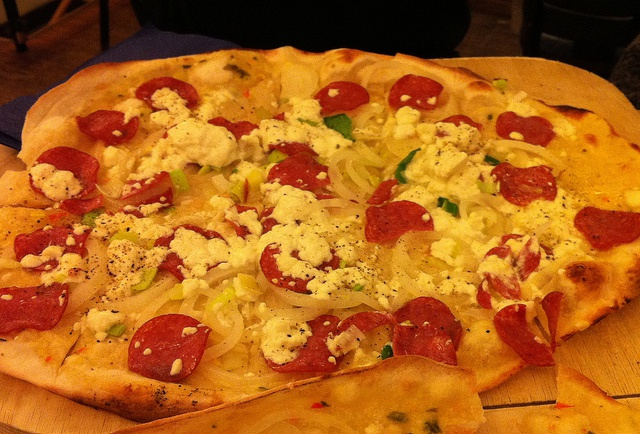Describe the objects in this image and their specific colors. I can see a pizza in maroon, orange, brown, and red tones in this image. 